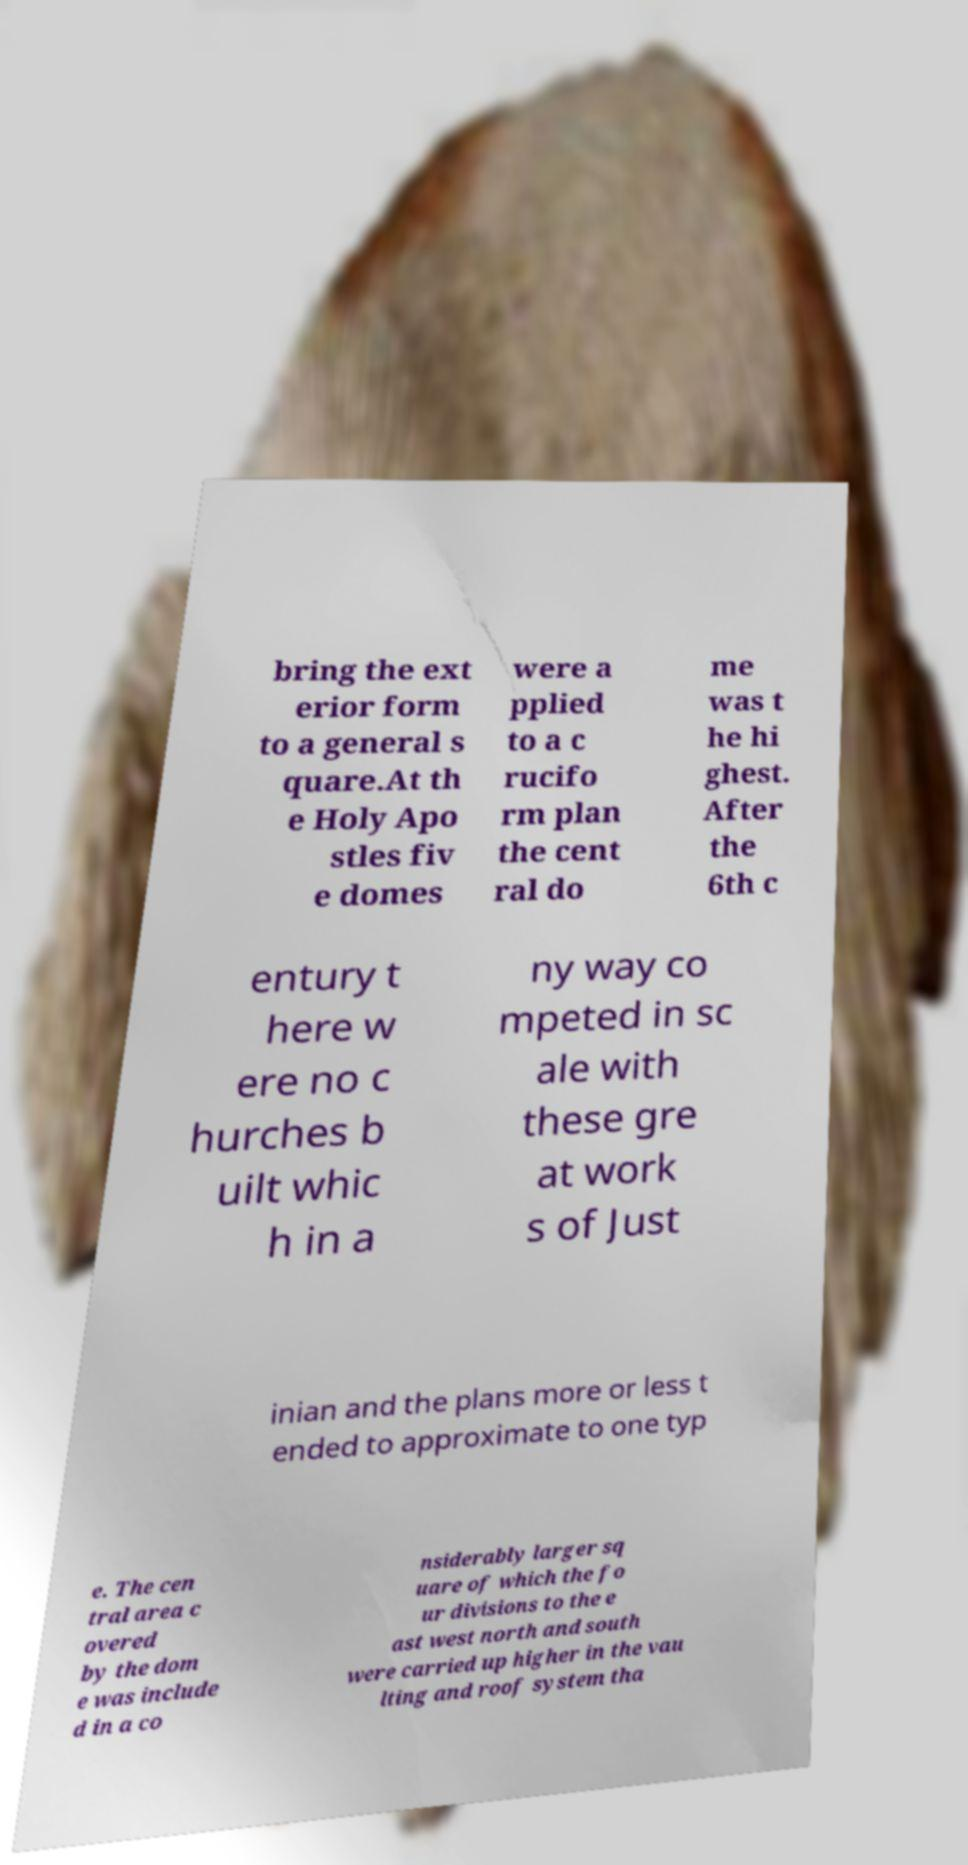Could you extract and type out the text from this image? bring the ext erior form to a general s quare.At th e Holy Apo stles fiv e domes were a pplied to a c rucifo rm plan the cent ral do me was t he hi ghest. After the 6th c entury t here w ere no c hurches b uilt whic h in a ny way co mpeted in sc ale with these gre at work s of Just inian and the plans more or less t ended to approximate to one typ e. The cen tral area c overed by the dom e was include d in a co nsiderably larger sq uare of which the fo ur divisions to the e ast west north and south were carried up higher in the vau lting and roof system tha 